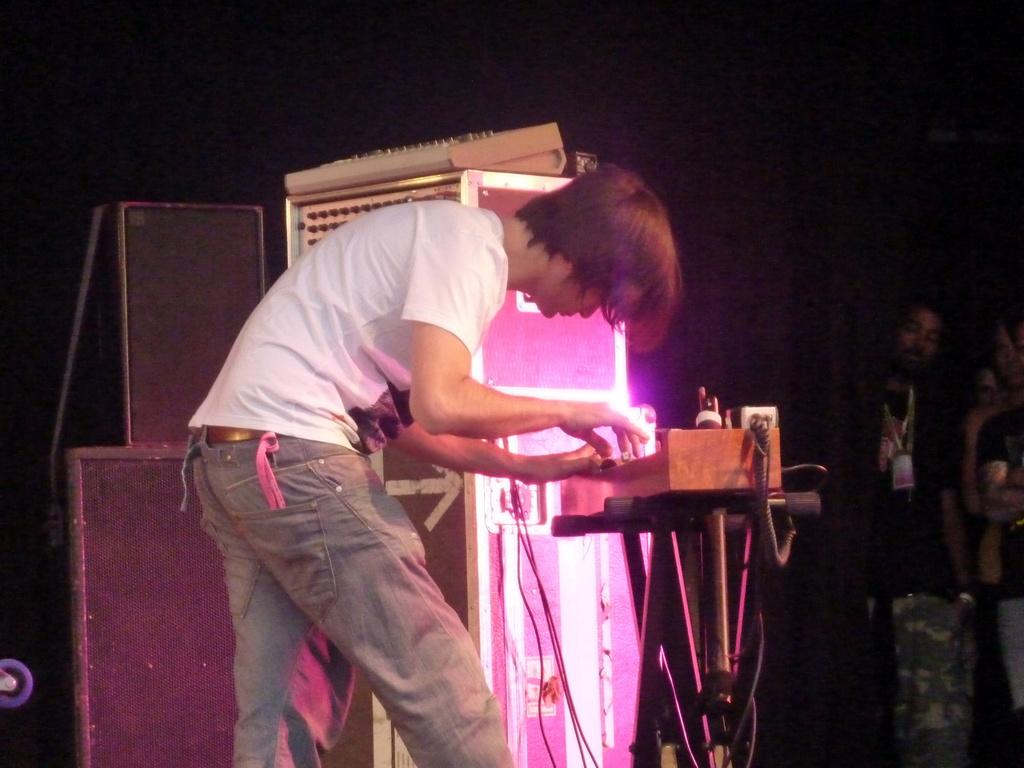How many people are present in the image? There are people in the image, but the exact number is not specified. What can be seen in the image besides people? There are speakers, musical instruments, boxes, and other objects in the image. What might be used for amplifying sound in the image? Speakers are present in the image for amplifying sound. What type of objects might be used for storing or organizing items in the image? Boxes are present in the image for storing or organizing items. What type of hair can be seen on the people in the image? There is no information about the people's hair in the image, so it cannot be determined. What type of holiday is being celebrated in the image? There is no indication of a holiday being celebrated in the image. What type of field is visible in the image? There is no field present in the image. 